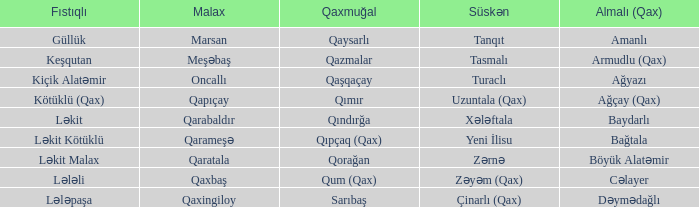What is the Almali village with the Malax village qaxingiloy? Dəymədağlı. 